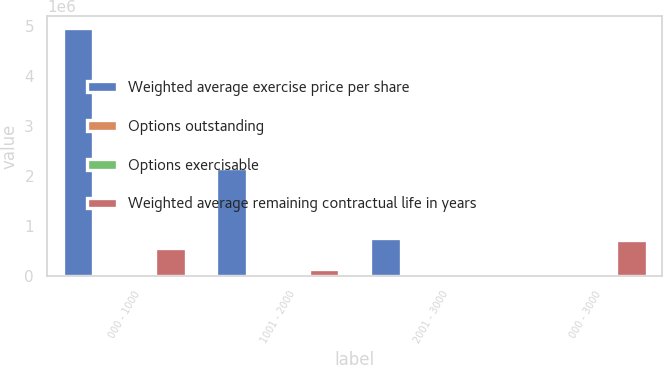Convert chart to OTSL. <chart><loc_0><loc_0><loc_500><loc_500><stacked_bar_chart><ecel><fcel>000 - 1000<fcel>1001 - 2000<fcel>2001 - 3000<fcel>000 - 3000<nl><fcel>Weighted average exercise price per share<fcel>4.94796e+06<fcel>2.16809e+06<fcel>769500<fcel>12.85<nl><fcel>Options outstanding<fcel>5<fcel>8.8<fcel>10.3<fcel>6.6<nl><fcel>Options exercisable<fcel>7.58<fcel>12.85<fcel>24.42<fcel>10.67<nl><fcel>Weighted average remaining contractual life in years<fcel>563685<fcel>147673<fcel>0<fcel>711358<nl></chart> 